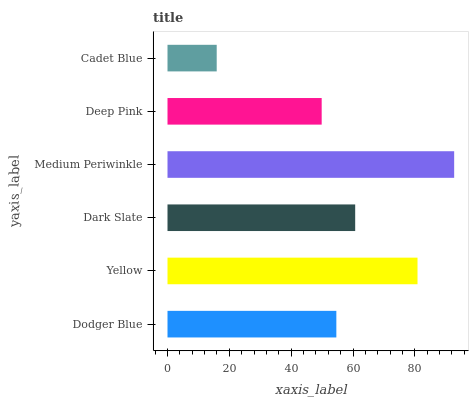Is Cadet Blue the minimum?
Answer yes or no. Yes. Is Medium Periwinkle the maximum?
Answer yes or no. Yes. Is Yellow the minimum?
Answer yes or no. No. Is Yellow the maximum?
Answer yes or no. No. Is Yellow greater than Dodger Blue?
Answer yes or no. Yes. Is Dodger Blue less than Yellow?
Answer yes or no. Yes. Is Dodger Blue greater than Yellow?
Answer yes or no. No. Is Yellow less than Dodger Blue?
Answer yes or no. No. Is Dark Slate the high median?
Answer yes or no. Yes. Is Dodger Blue the low median?
Answer yes or no. Yes. Is Yellow the high median?
Answer yes or no. No. Is Medium Periwinkle the low median?
Answer yes or no. No. 